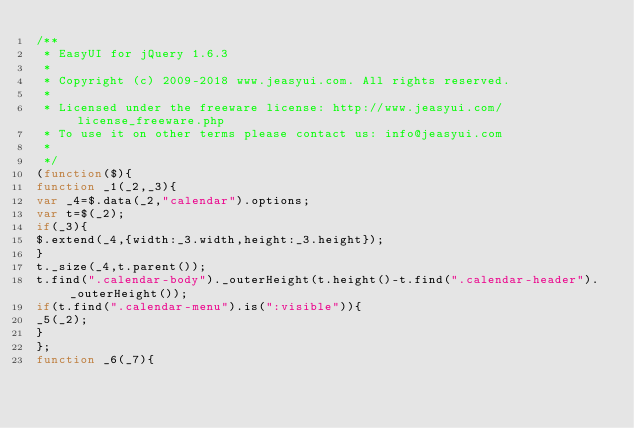Convert code to text. <code><loc_0><loc_0><loc_500><loc_500><_JavaScript_>/**
 * EasyUI for jQuery 1.6.3
 * 
 * Copyright (c) 2009-2018 www.jeasyui.com. All rights reserved.
 *
 * Licensed under the freeware license: http://www.jeasyui.com/license_freeware.php
 * To use it on other terms please contact us: info@jeasyui.com
 *
 */
(function($){
function _1(_2,_3){
var _4=$.data(_2,"calendar").options;
var t=$(_2);
if(_3){
$.extend(_4,{width:_3.width,height:_3.height});
}
t._size(_4,t.parent());
t.find(".calendar-body")._outerHeight(t.height()-t.find(".calendar-header")._outerHeight());
if(t.find(".calendar-menu").is(":visible")){
_5(_2);
}
};
function _6(_7){</code> 